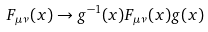Convert formula to latex. <formula><loc_0><loc_0><loc_500><loc_500>F _ { \mu \nu } ( x ) \rightarrow g ^ { - 1 } ( x ) F _ { \mu \nu } ( x ) g ( x )</formula> 